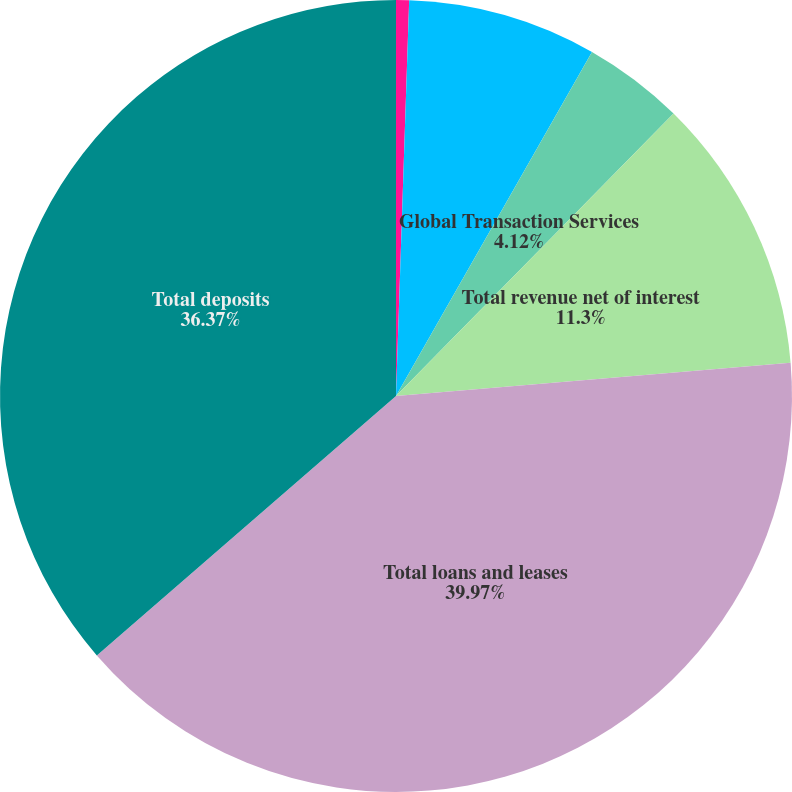Convert chart to OTSL. <chart><loc_0><loc_0><loc_500><loc_500><pie_chart><fcel>(Dollars in millions)<fcel>Business Lending<fcel>Global Transaction Services<fcel>Total revenue net of interest<fcel>Total loans and leases<fcel>Total deposits<nl><fcel>0.53%<fcel>7.71%<fcel>4.12%<fcel>11.3%<fcel>39.97%<fcel>36.37%<nl></chart> 